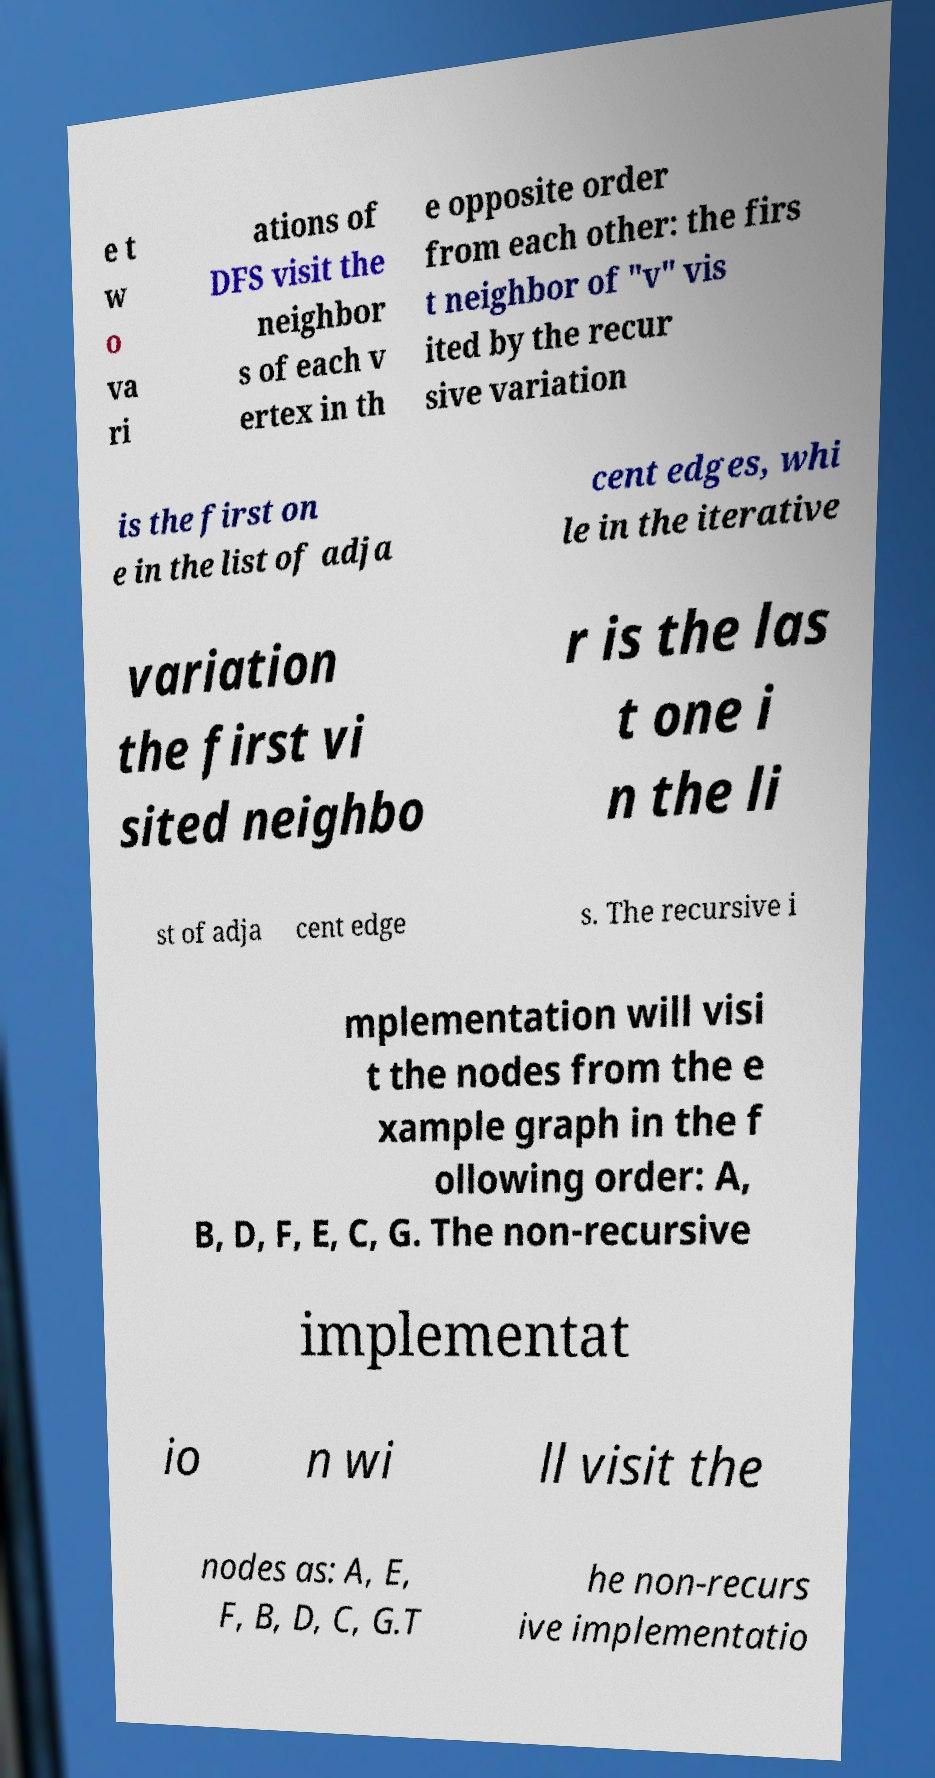For documentation purposes, I need the text within this image transcribed. Could you provide that? e t w o va ri ations of DFS visit the neighbor s of each v ertex in th e opposite order from each other: the firs t neighbor of "v" vis ited by the recur sive variation is the first on e in the list of adja cent edges, whi le in the iterative variation the first vi sited neighbo r is the las t one i n the li st of adja cent edge s. The recursive i mplementation will visi t the nodes from the e xample graph in the f ollowing order: A, B, D, F, E, C, G. The non-recursive implementat io n wi ll visit the nodes as: A, E, F, B, D, C, G.T he non-recurs ive implementatio 